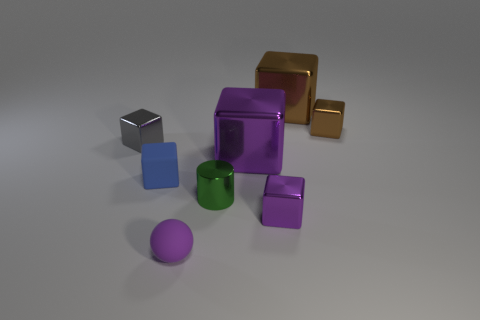How big is the matte ball?
Offer a terse response. Small. There is a large object that is the same color as the ball; what is its shape?
Provide a short and direct response. Cube. Is the number of small green things greater than the number of brown spheres?
Your response must be concise. Yes. There is a tiny metallic thing that is behind the metallic cube that is left of the purple metallic thing behind the small purple shiny thing; what is its color?
Offer a very short reply. Brown. Does the purple thing behind the tiny blue rubber thing have the same shape as the gray thing?
Provide a succinct answer. Yes. There is a cylinder that is the same size as the purple rubber sphere; what color is it?
Offer a terse response. Green. How many big blue cylinders are there?
Ensure brevity in your answer.  0. Is the material of the small purple object on the right side of the small purple rubber sphere the same as the tiny purple sphere?
Offer a terse response. No. There is a cube that is both behind the blue cube and to the left of the small ball; what material is it?
Keep it short and to the point. Metal. What is the material of the purple thing that is in front of the purple metal thing that is in front of the tiny rubber block?
Ensure brevity in your answer.  Rubber. 